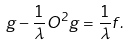<formula> <loc_0><loc_0><loc_500><loc_500>g - \frac { 1 } { \lambda } O ^ { 2 } g = \frac { 1 } { \lambda } f .</formula> 